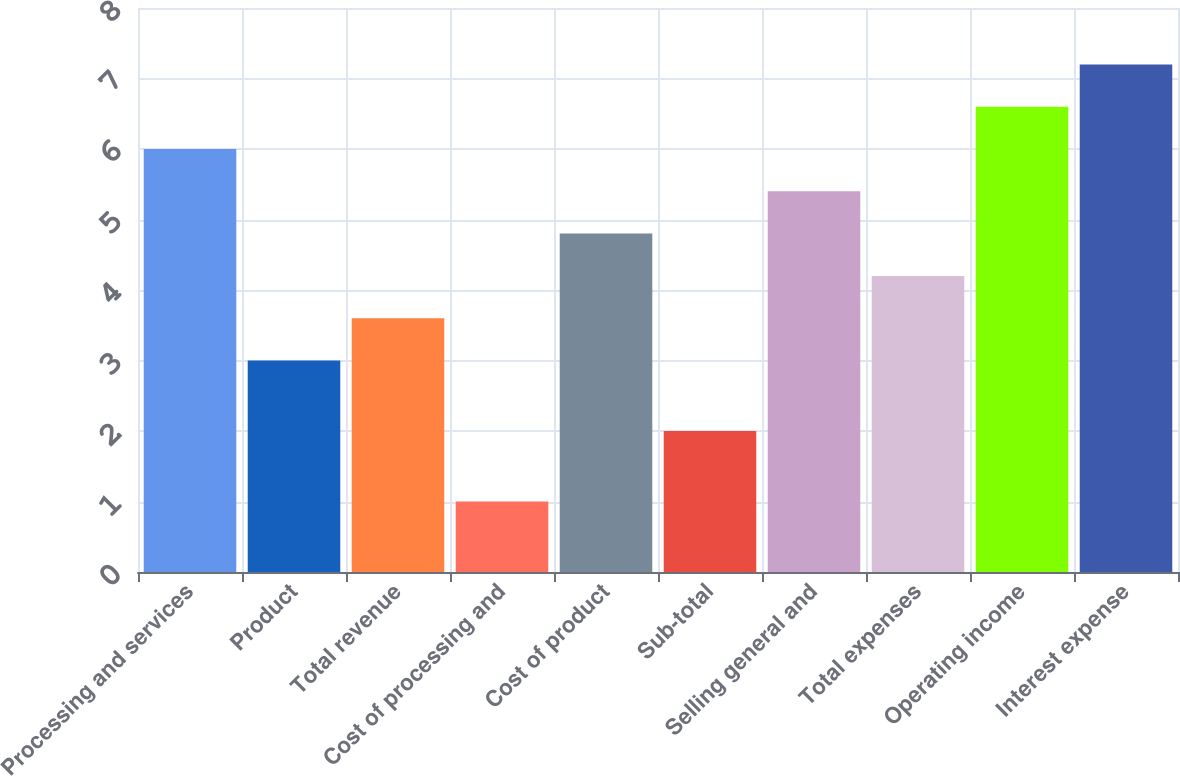Convert chart. <chart><loc_0><loc_0><loc_500><loc_500><bar_chart><fcel>Processing and services<fcel>Product<fcel>Total revenue<fcel>Cost of processing and<fcel>Cost of product<fcel>Sub-total<fcel>Selling general and<fcel>Total expenses<fcel>Operating income<fcel>Interest expense<nl><fcel>6<fcel>3<fcel>3.6<fcel>1<fcel>4.8<fcel>2<fcel>5.4<fcel>4.2<fcel>6.6<fcel>7.2<nl></chart> 